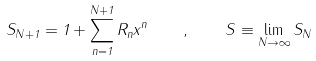<formula> <loc_0><loc_0><loc_500><loc_500>S _ { N + 1 } = 1 + \sum _ { n = 1 } ^ { N + 1 } R _ { n } x ^ { n } \quad , \quad S \equiv \lim _ { N \rightarrow \infty } S _ { N }</formula> 